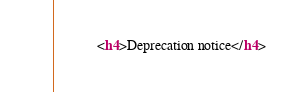Convert code to text. <code><loc_0><loc_0><loc_500><loc_500><_HTML_>            <h4>Deprecation notice</h4></code> 